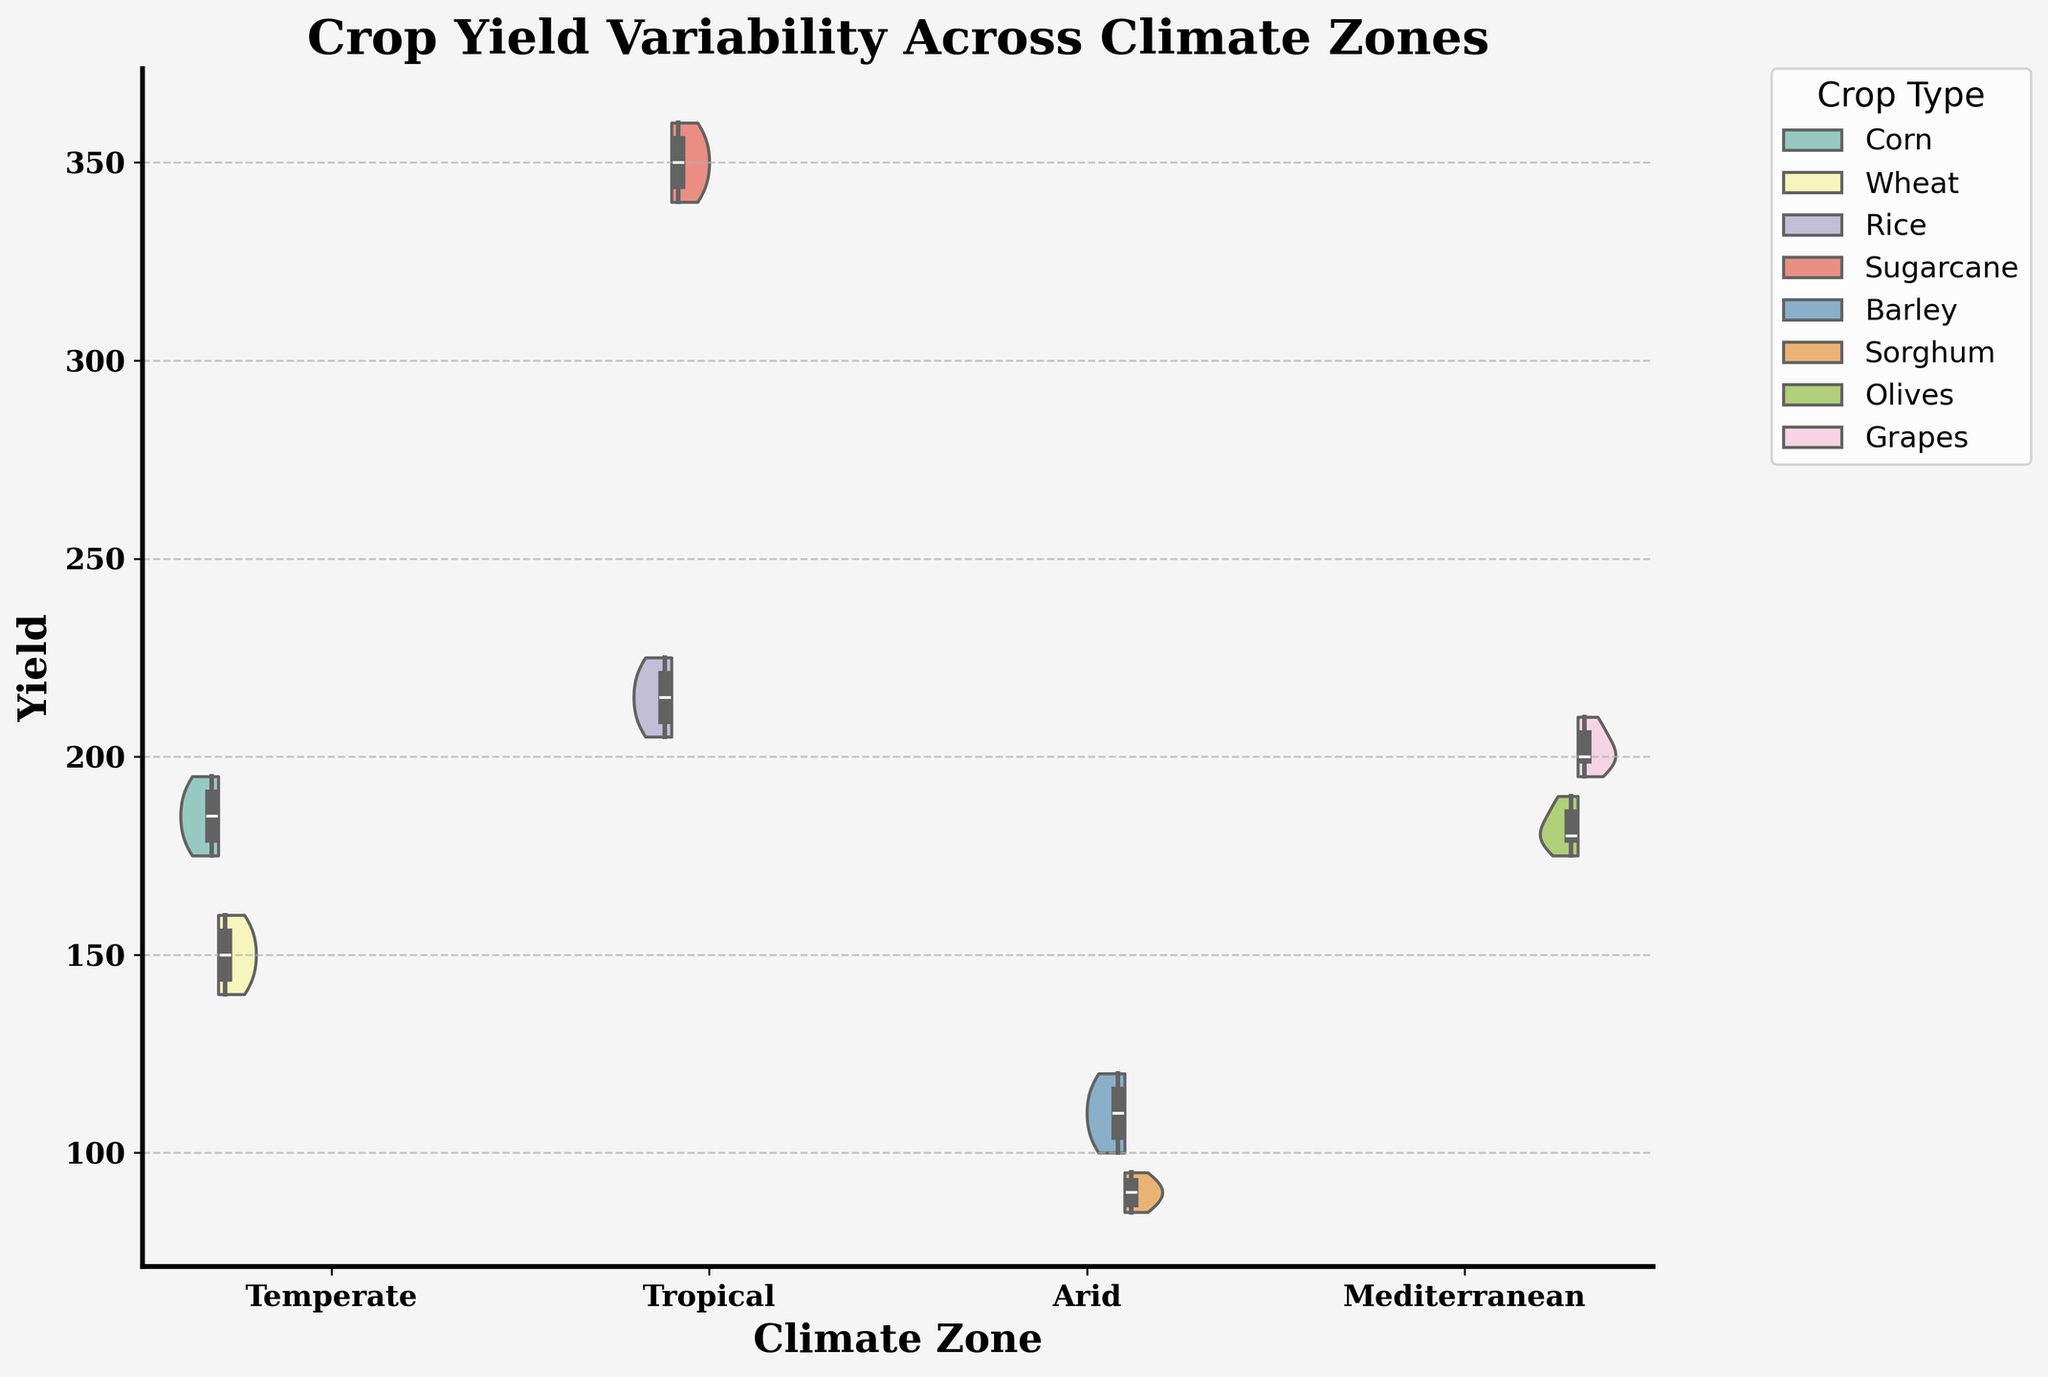What is the title of the figure? The title is usually positioned at the top center of the figure. It reads "Crop Yield Variability Across Climate Zones".
Answer: Crop Yield Variability Across Climate Zones Which climate zone has the highest yield for grapes? Looking at the Mediterranean climate zone, observe the higher end of the distribution violin for grapes. The yields are around 205 and 210.
Answer: Mediterranean How many different crop types are displayed for the Tropical climate zone? Check the legend on the upper right for crop types, then look at their corresponding sections in the Tropical zone. There are two crop types: Rice and Sugarcane.
Answer: Two What are the median yields for wheat and corn in the Temperate climate zone? Observe the box plot within the violin for each crop type in the Temperate climate zone. For Wheat, the median is centered in its box at 150, and for Corn, it is centered at 185.
Answer: Wheat: 150, Corn: 185 Which climate zone shows the most significant variability in yields for any crop? Variability can be gauged by observing the width and spread of the violin plots. The Tropical climate zone shows a substantial spread for Sugarcane, indicating high variability.
Answer: Tropical How do the yields of sorghum in the Arid zone compare to those of barley in the same zone? Compare the spreads of the violin plots for Sorghum and Barley in the Arid zone. Sorghum yields range between 85 to 95, while Barley ranges between 100 to 120, indicating Barley yields are generally higher.
Answer: Barley yields are higher What is the range of olive yields in the Mediterranean climate zone? The range is obtained by taking the minimum and maximum points in the violin plot for olives. The minimum is around 175, and the maximum is approximately 190.
Answer: 175 to 190 Which crop type in the Arid climate zone has the lower median yield and by how much? Observe the median lines within the violins for Barley and Sorghum. Barley has a median yield of around 110, and Sorghum has about 90. Therefore, Sorghum is lower by 20 units.
Answer: Sorghum, by 20 units What are the maximum and minimum yields for rice in the Tropical climate zone? Identify the highest and lowest points on the rice violin plot in the Tropical climate zone. The maximum is around 225, and the minimum is approximately 205.
Answer: Maximum: 225, Minimum: 205 Which crop type has the least variability in yields in the Temperate climate zone? Find the crop with the narrowest and least spread violin plot. Wheat shows a narrower distribution compared to Corn, indicating less variability.
Answer: Wheat 